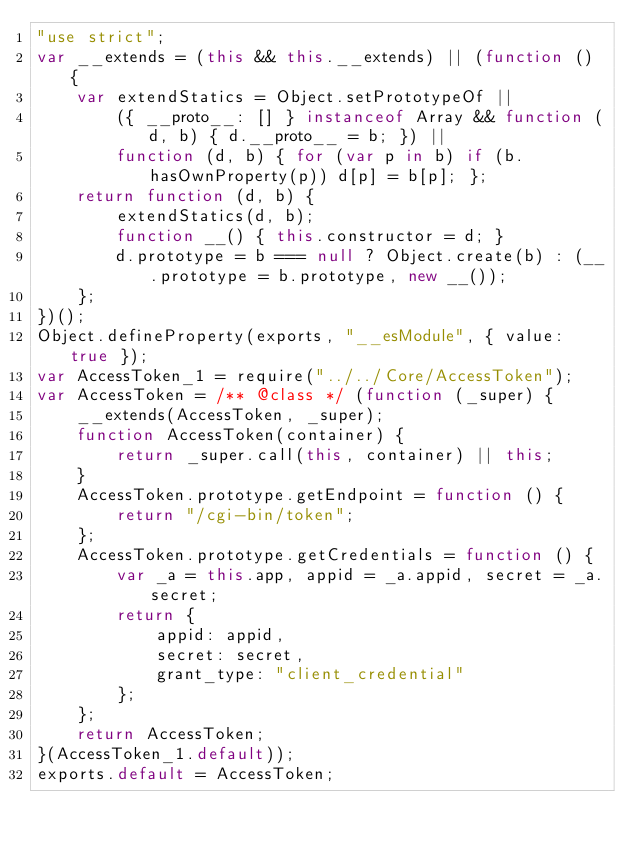<code> <loc_0><loc_0><loc_500><loc_500><_JavaScript_>"use strict";
var __extends = (this && this.__extends) || (function () {
    var extendStatics = Object.setPrototypeOf ||
        ({ __proto__: [] } instanceof Array && function (d, b) { d.__proto__ = b; }) ||
        function (d, b) { for (var p in b) if (b.hasOwnProperty(p)) d[p] = b[p]; };
    return function (d, b) {
        extendStatics(d, b);
        function __() { this.constructor = d; }
        d.prototype = b === null ? Object.create(b) : (__.prototype = b.prototype, new __());
    };
})();
Object.defineProperty(exports, "__esModule", { value: true });
var AccessToken_1 = require("../../Core/AccessToken");
var AccessToken = /** @class */ (function (_super) {
    __extends(AccessToken, _super);
    function AccessToken(container) {
        return _super.call(this, container) || this;
    }
    AccessToken.prototype.getEndpoint = function () {
        return "/cgi-bin/token";
    };
    AccessToken.prototype.getCredentials = function () {
        var _a = this.app, appid = _a.appid, secret = _a.secret;
        return {
            appid: appid,
            secret: secret,
            grant_type: "client_credential"
        };
    };
    return AccessToken;
}(AccessToken_1.default));
exports.default = AccessToken;
</code> 